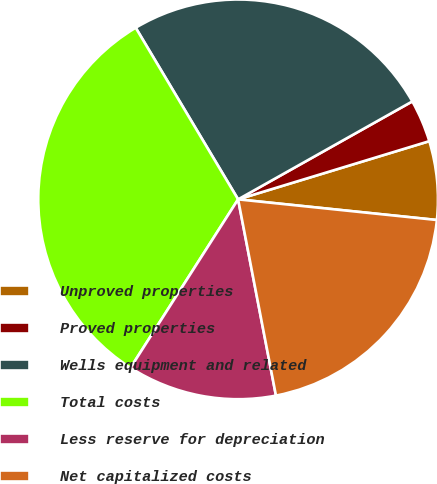Convert chart. <chart><loc_0><loc_0><loc_500><loc_500><pie_chart><fcel>Unproved properties<fcel>Proved properties<fcel>Wells equipment and related<fcel>Total costs<fcel>Less reserve for depreciation<fcel>Net capitalized costs<nl><fcel>6.35%<fcel>3.45%<fcel>25.41%<fcel>32.39%<fcel>12.08%<fcel>20.32%<nl></chart> 